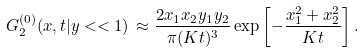<formula> <loc_0><loc_0><loc_500><loc_500>G _ { 2 } ^ { ( 0 ) } ( { x } , t | { y } < < 1 ) \, \approx \frac { 2 x _ { 1 } x _ { 2 } y _ { 1 } y _ { 2 } } { \pi ( K t ) ^ { 3 } } \exp \left [ { - \frac { x _ { 1 } ^ { 2 } + x _ { 2 } ^ { 2 } } { K t } } \right ] .</formula> 